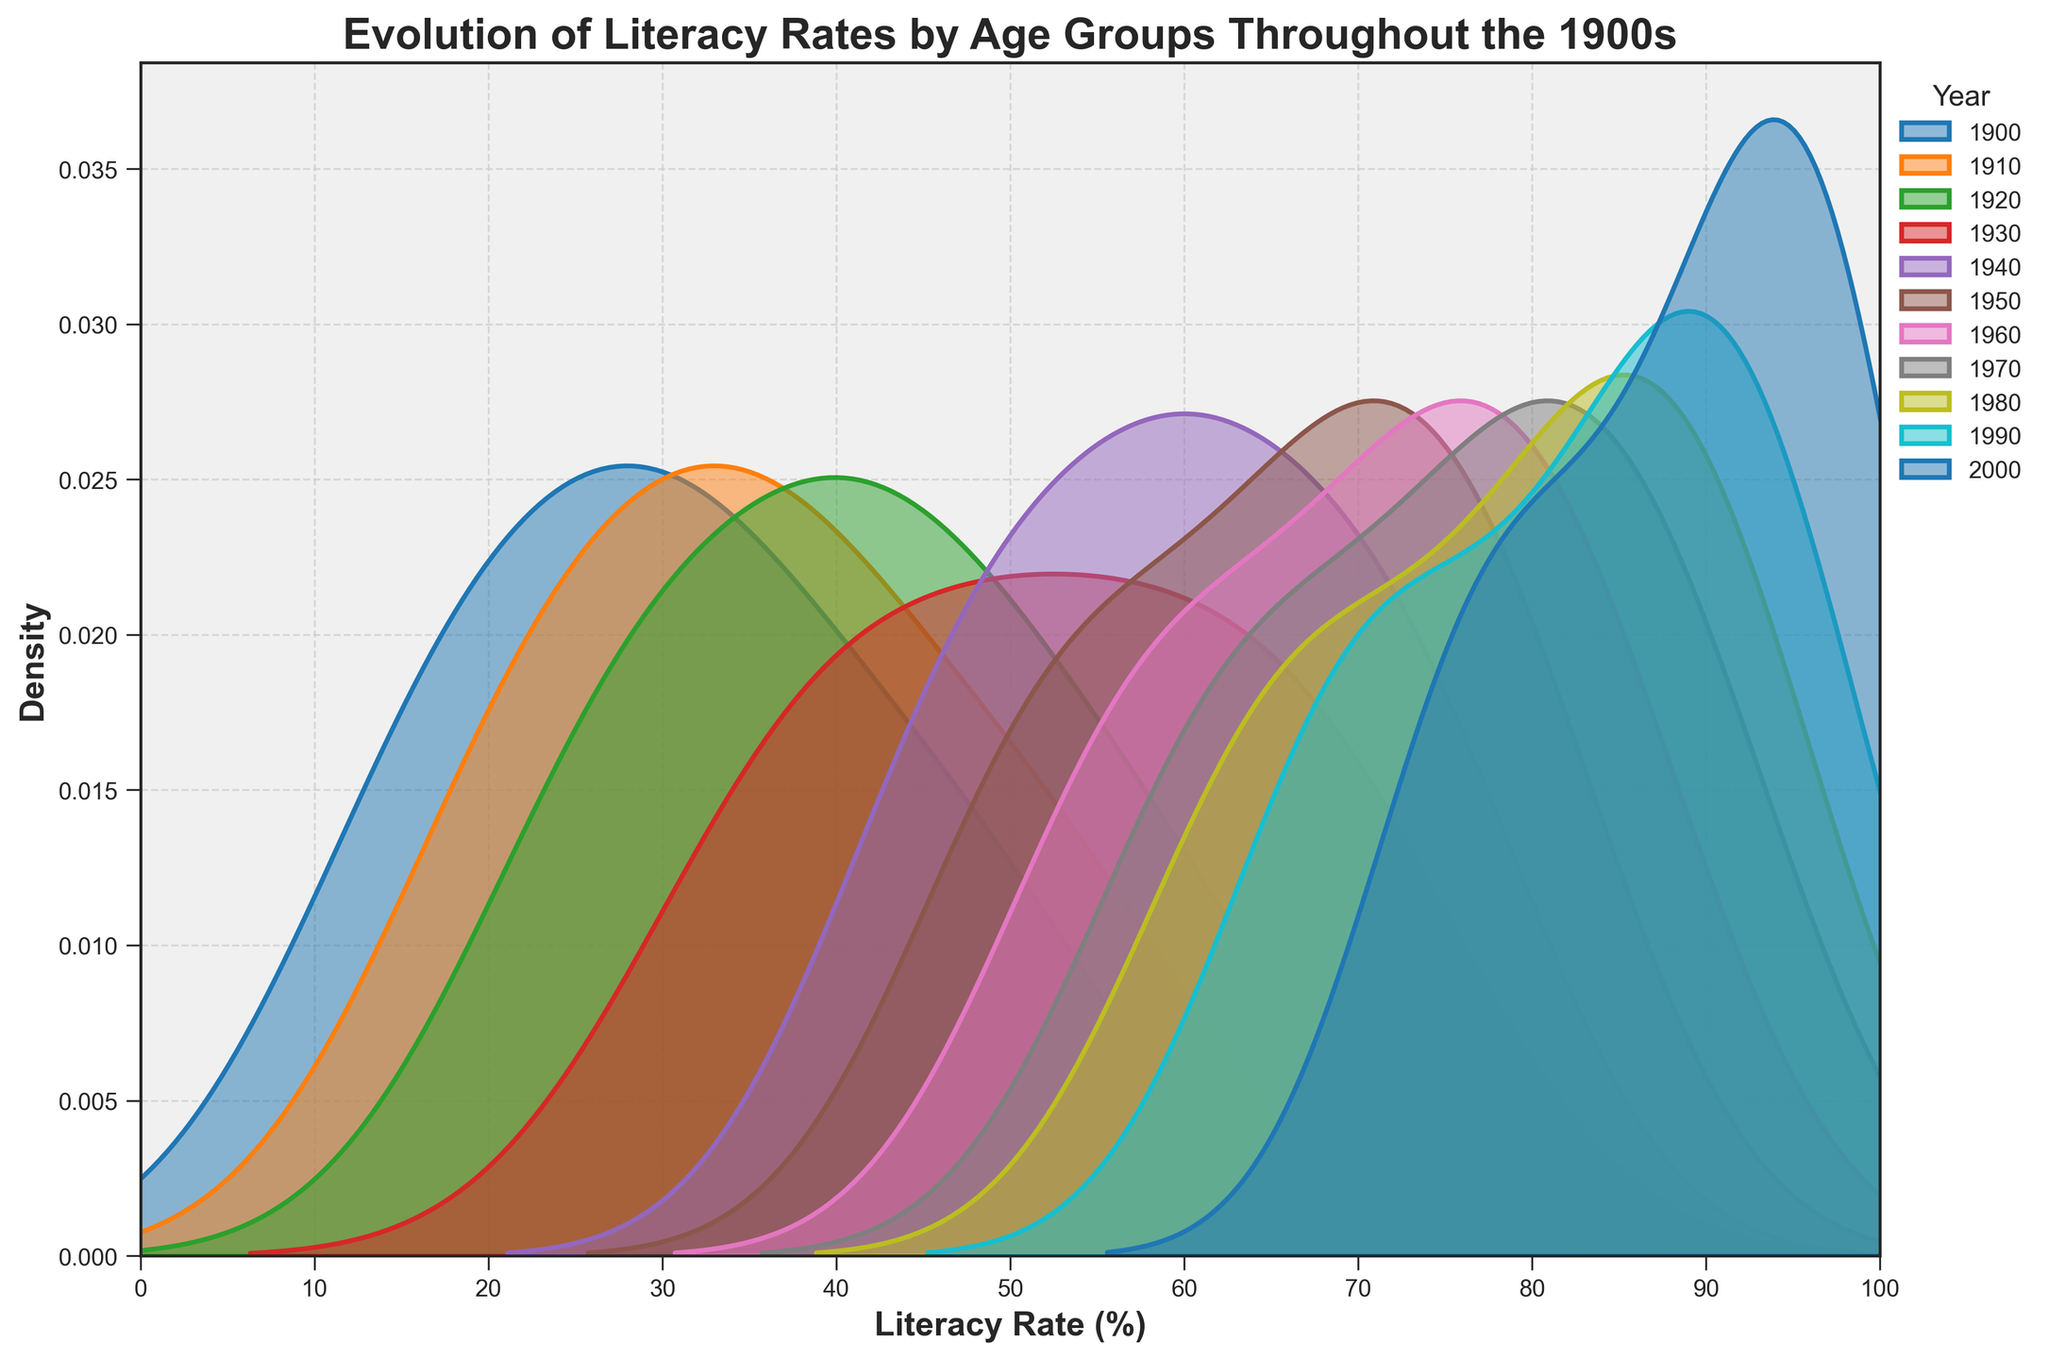What is the title of the plot? The title is the text at the top of the plot, which typically provides a summary of what the plot represents. By referring to the text at the top, we see it is "Evolution of Literacy Rates by Age Groups Throughout the 1900s".
Answer: Evolution of Literacy Rates by Age Groups Throughout the 1900s What is the x-axis label? The x-axis label is the text below the x-axis that indicates what the x-axis represents. Here, it is labeled "Literacy Rate (%)", which tells us this axis shows literacy rates as percentages.
Answer: Literacy Rate (%) What is the y-axis label? The y-axis label is the text next to the y-axis that indicates what the y-axis represents. For this plot, it is "Density", telling us this axis shows the density of the literacy rates.
Answer: Density Which year has the highest peak in literacy rates? To find the year with the highest peak in literacy rates, we look for the density line with the highest peak on the plot. The line for the year 2000 has the highest peak, indicating the highest literacy rates in that year.
Answer: 2000 How did literacy rates for 10-19 age group evolve from 1900 to 2000? By referring to the various density lines for each year, we notice the peak values for the 10-19 age group increase steadily over time. Starting at 30 in 1900 and peaking at 95 in 2000. This demonstrates a significant rise in literacy rates over the century for this age group.
Answer: Increased significantly Which age group shows the most improvement in literacy from 1900 to 2000? To determine which age group shows the most improvement, we compare the literacy rates of each age group in 1900 and 2000. The 10-19 age group improved from 30% to 95%, indicating the most significant improvement.
Answer: 10-19 How does the literacy rate distribution in 1950 compare to that in 1900? Comparing the density lines for 1950 and 1900, we see the peaks for 1950 are much higher and further to the right than those for 1900, suggesting higher and more concentrated literacy rates in 1950 compared to 1900.
Answer: Higher and more concentrated Which age group had the lowest literacy rate in the 1910s? Observing the 1910 density line, the lowest peak corresponds to the 60+ age group, indicating they had the lowest literacy rate in the 1910s.
Answer: 60+ Did the literacy rate for the 50-59 age group ever surpass 80% between 1900 to 2000? Examining the density lines for the years between 1900 and 2000, we see that the literacy rate for the 50-59 age group never surpasses 80% in any year.
Answer: No 